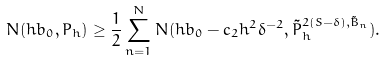<formula> <loc_0><loc_0><loc_500><loc_500>N ( h b _ { 0 } , P _ { h } ) \geq \frac { 1 } { 2 } \sum _ { n = 1 } ^ { N } N ( h b _ { 0 } - c _ { 2 } h ^ { 2 } \delta ^ { - 2 } , \tilde { P } _ { h } ^ { 2 ( S - \delta ) , \tilde { B } _ { n } } ) .</formula> 